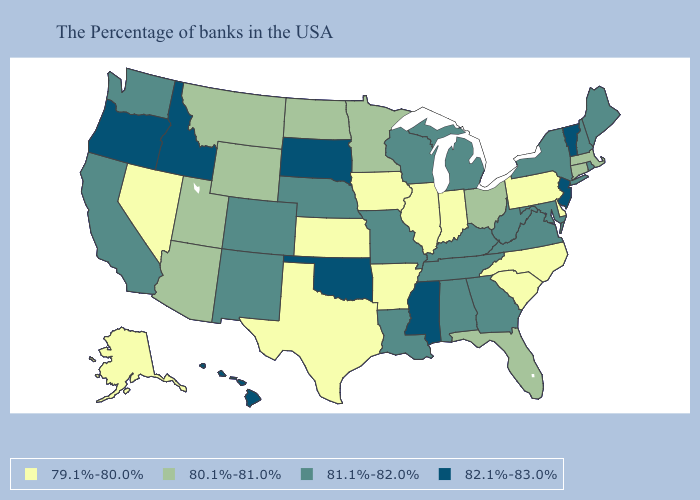What is the lowest value in the USA?
Write a very short answer. 79.1%-80.0%. Name the states that have a value in the range 82.1%-83.0%?
Be succinct. Vermont, New Jersey, Mississippi, Oklahoma, South Dakota, Idaho, Oregon, Hawaii. Among the states that border Mississippi , does Alabama have the lowest value?
Quick response, please. No. Among the states that border Virginia , does Kentucky have the highest value?
Write a very short answer. Yes. Among the states that border Arizona , which have the highest value?
Concise answer only. Colorado, New Mexico, California. Name the states that have a value in the range 79.1%-80.0%?
Concise answer only. Delaware, Pennsylvania, North Carolina, South Carolina, Indiana, Illinois, Arkansas, Iowa, Kansas, Texas, Nevada, Alaska. Which states have the lowest value in the USA?
Quick response, please. Delaware, Pennsylvania, North Carolina, South Carolina, Indiana, Illinois, Arkansas, Iowa, Kansas, Texas, Nevada, Alaska. What is the value of North Carolina?
Short answer required. 79.1%-80.0%. Which states hav the highest value in the West?
Write a very short answer. Idaho, Oregon, Hawaii. Does the map have missing data?
Answer briefly. No. What is the value of South Carolina?
Short answer required. 79.1%-80.0%. Which states hav the highest value in the West?
Be succinct. Idaho, Oregon, Hawaii. Does Oklahoma have the highest value in the USA?
Quick response, please. Yes. What is the highest value in states that border Nebraska?
Keep it brief. 82.1%-83.0%. Name the states that have a value in the range 80.1%-81.0%?
Be succinct. Massachusetts, Connecticut, Ohio, Florida, Minnesota, North Dakota, Wyoming, Utah, Montana, Arizona. 